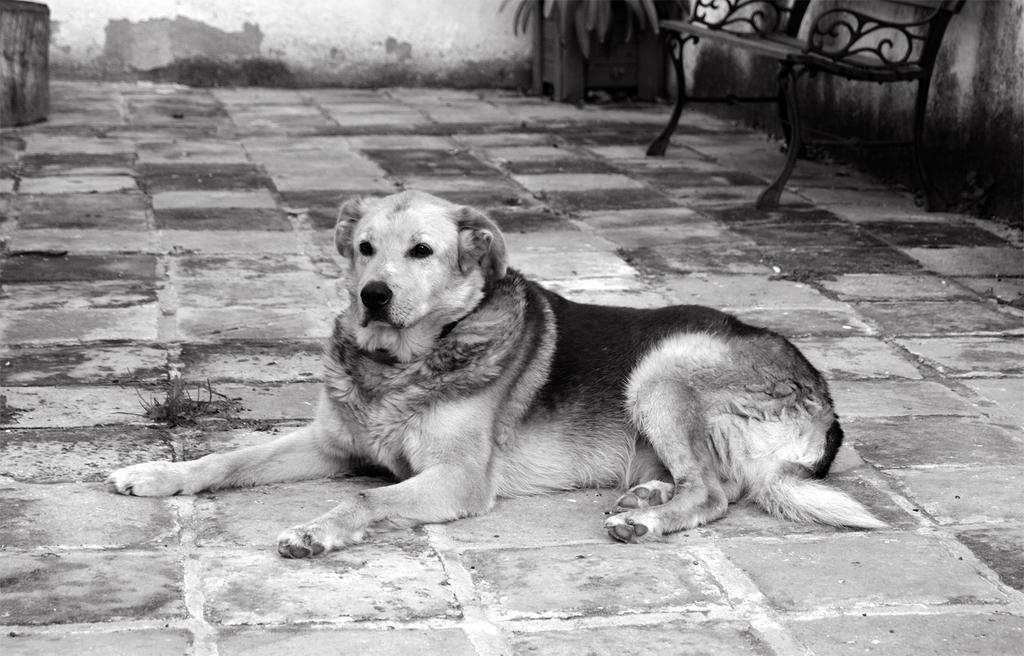What is the color scheme of the image? The image is black and white. What animal can be seen in the image? There is a dog in the image. Where is the bench located in the image? The bench is on the right side of the image. What is visible at the bottom of the image? There is a floor visible at the bottom of the image. How many lizards are crawling through the hole in the image? There are no lizards or holes present in the image. What type of ticket is visible on the bench in the image? There is no ticket visible on the bench in the image. 